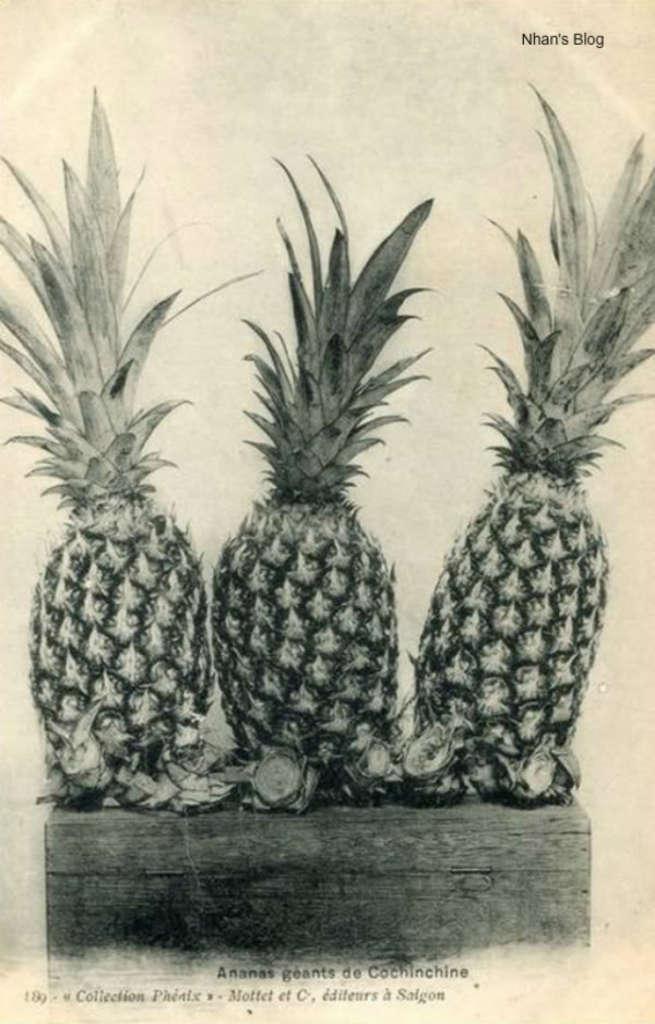How would you summarize this image in a sentence or two? This is a poster. In this poster we can see there is an image of three pineapples placed on a wooden table. 